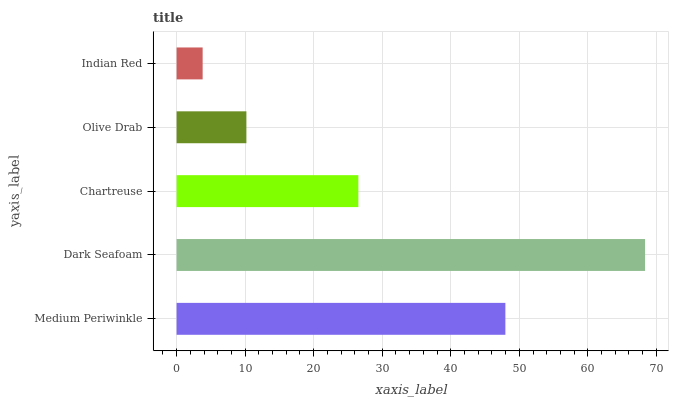Is Indian Red the minimum?
Answer yes or no. Yes. Is Dark Seafoam the maximum?
Answer yes or no. Yes. Is Chartreuse the minimum?
Answer yes or no. No. Is Chartreuse the maximum?
Answer yes or no. No. Is Dark Seafoam greater than Chartreuse?
Answer yes or no. Yes. Is Chartreuse less than Dark Seafoam?
Answer yes or no. Yes. Is Chartreuse greater than Dark Seafoam?
Answer yes or no. No. Is Dark Seafoam less than Chartreuse?
Answer yes or no. No. Is Chartreuse the high median?
Answer yes or no. Yes. Is Chartreuse the low median?
Answer yes or no. Yes. Is Olive Drab the high median?
Answer yes or no. No. Is Dark Seafoam the low median?
Answer yes or no. No. 